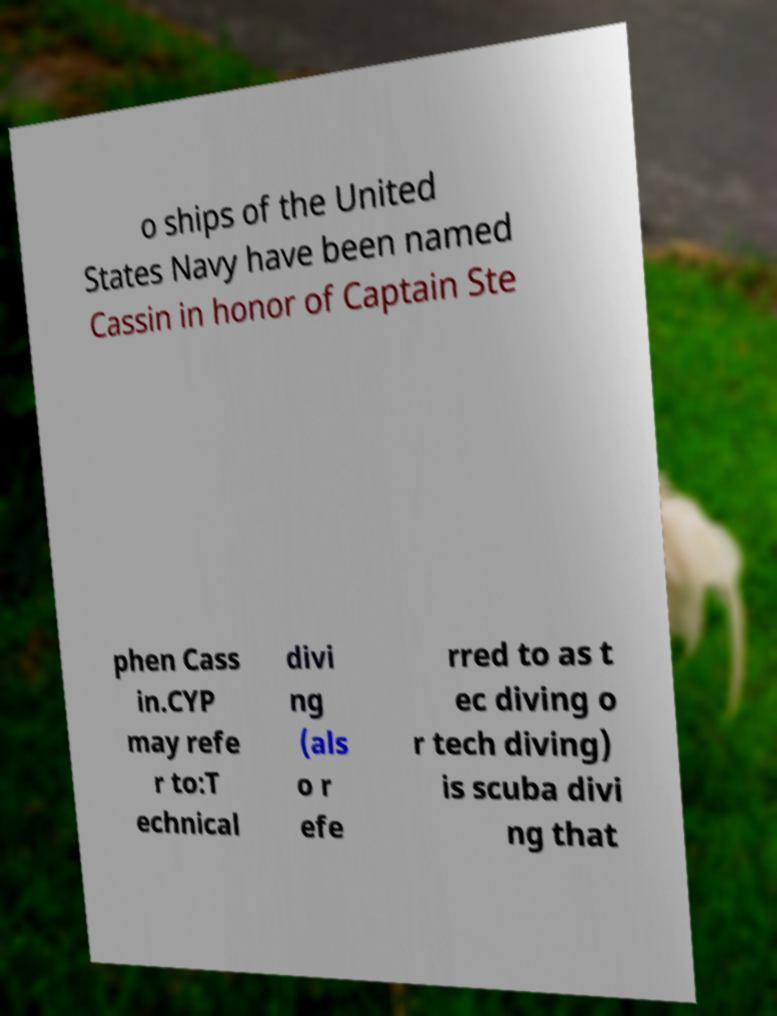Can you accurately transcribe the text from the provided image for me? o ships of the United States Navy have been named Cassin in honor of Captain Ste phen Cass in.CYP may refe r to:T echnical divi ng (als o r efe rred to as t ec diving o r tech diving) is scuba divi ng that 